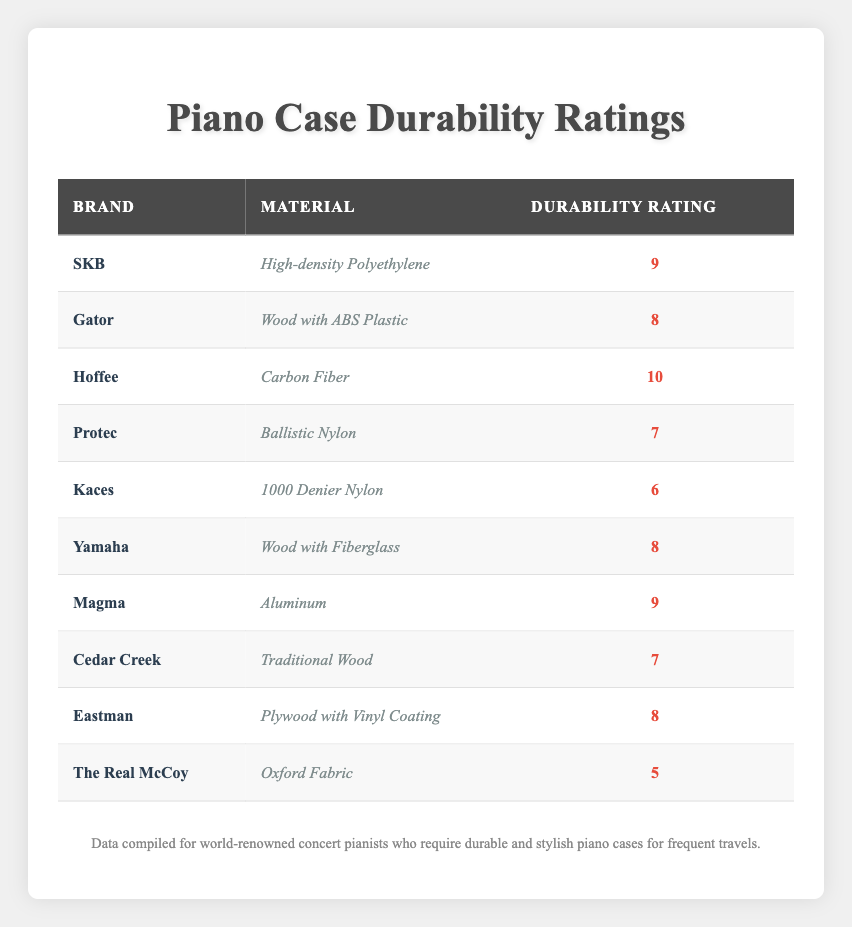What is the highest durability rating among the piano cases? The table lists the durability ratings for each brand, with Hoffee having a rating of 10, which is the highest.
Answer: 10 How many brands have a durability rating of 8? Referring to the table, both Gator, Yamaha, and Eastman have a durability rating of 8, so there are three brands.
Answer: 3 Is the rating for Gator higher than that for Kaces? Gator has a rating of 8 and Kaces has a rating of 6, so Gator's rating is indeed higher.
Answer: Yes What is the average durability rating of the brands that use wood-based materials? The wood-based brands are Gator (8), Yamaha (8), Cedar Creek (7), and Eastman (8). Their sum is 8 + 8 + 7 + 8 = 31. There are 4 brands, so the average is 31 divided by 4, which is 7.75.
Answer: 7.75 How many brands have a durability rating of 7 or lower? The brands with a rating of 7 or lower are Protec (7), Cedar Creek (7), Kaces (6), and The Real McCoy (5). This totals four brands.
Answer: 4 Is there a brand using a material that includes "Nylon" and has a durability rating of 7 or higher? The brands using nylon are Protec (7) and Kaces (6). Only Protec has a durability rating of 7 or higher, therefore the answer is yes.
Answer: Yes Which brand with a durability rating of 9 uses aluminum as a material? The brand Magma is listed in the table with a durability rating of 9 and uses aluminum as a material.
Answer: Magma What is the difference between the highest and lowest durability ratings in the table? The highest rating is 10 for Hoffee and the lowest is 5 for The Real McCoy. The difference is 10 - 5 = 5.
Answer: 5 Which material category has the highest rated item, and what is that rating? Analyzing the materials, carbon fiber (used by Hoffee) has the highest rating of 10, which is the best performance overall.
Answer: Carbon Fiber, 10 